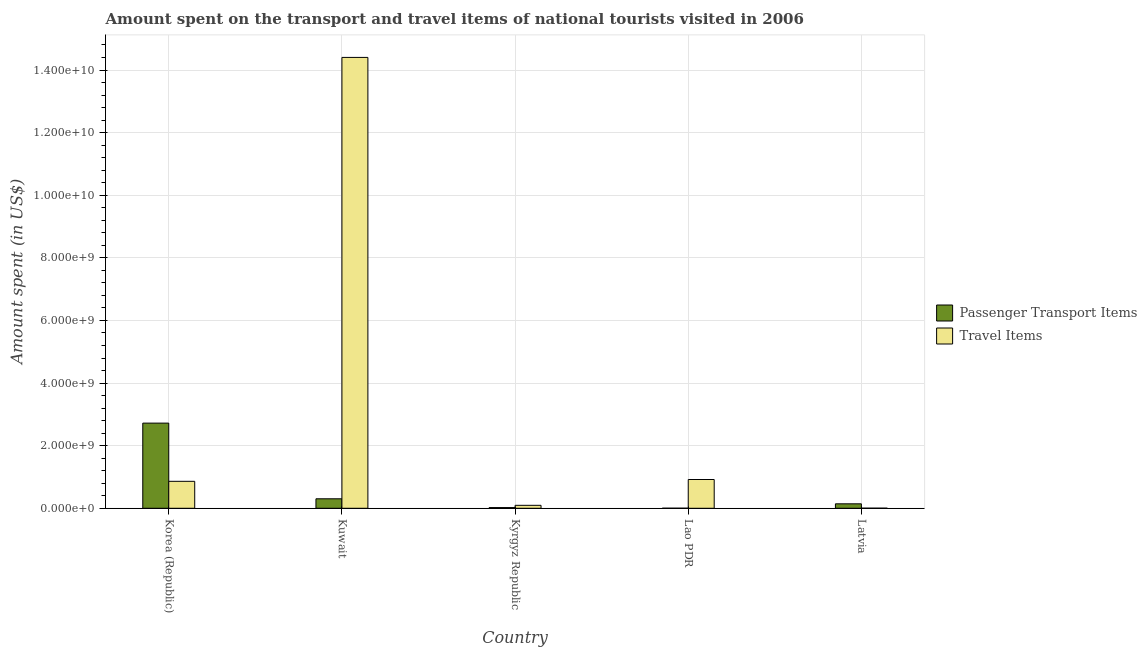How many bars are there on the 4th tick from the right?
Keep it short and to the point. 2. What is the label of the 4th group of bars from the left?
Provide a succinct answer. Lao PDR. In how many cases, is the number of bars for a given country not equal to the number of legend labels?
Your answer should be compact. 0. What is the amount spent in travel items in Kyrgyz Republic?
Ensure brevity in your answer.  9.40e+07. Across all countries, what is the maximum amount spent in travel items?
Offer a very short reply. 1.44e+1. Across all countries, what is the minimum amount spent in travel items?
Give a very brief answer. 2.80e+06. In which country was the amount spent on passenger transport items maximum?
Your answer should be compact. Korea (Republic). In which country was the amount spent on passenger transport items minimum?
Provide a short and direct response. Lao PDR. What is the total amount spent in travel items in the graph?
Offer a very short reply. 1.63e+1. What is the difference between the amount spent in travel items in Kuwait and that in Latvia?
Provide a succinct answer. 1.44e+1. What is the difference between the amount spent in travel items in Kyrgyz Republic and the amount spent on passenger transport items in Kuwait?
Your response must be concise. -2.09e+08. What is the average amount spent in travel items per country?
Provide a succinct answer. 3.26e+09. What is the difference between the amount spent on passenger transport items and amount spent in travel items in Korea (Republic)?
Provide a succinct answer. 1.86e+09. What is the ratio of the amount spent in travel items in Korea (Republic) to that in Lao PDR?
Ensure brevity in your answer.  0.94. What is the difference between the highest and the second highest amount spent in travel items?
Give a very brief answer. 1.35e+1. What is the difference between the highest and the lowest amount spent on passenger transport items?
Keep it short and to the point. 2.72e+09. What does the 2nd bar from the left in Kyrgyz Republic represents?
Your answer should be compact. Travel Items. What does the 1st bar from the right in Lao PDR represents?
Offer a terse response. Travel Items. What is the difference between two consecutive major ticks on the Y-axis?
Your answer should be very brief. 2.00e+09. Are the values on the major ticks of Y-axis written in scientific E-notation?
Ensure brevity in your answer.  Yes. Does the graph contain grids?
Keep it short and to the point. Yes. Where does the legend appear in the graph?
Give a very brief answer. Center right. How many legend labels are there?
Provide a succinct answer. 2. How are the legend labels stacked?
Your response must be concise. Vertical. What is the title of the graph?
Offer a very short reply. Amount spent on the transport and travel items of national tourists visited in 2006. What is the label or title of the Y-axis?
Offer a very short reply. Amount spent (in US$). What is the Amount spent (in US$) in Passenger Transport Items in Korea (Republic)?
Your response must be concise. 2.72e+09. What is the Amount spent (in US$) in Travel Items in Korea (Republic)?
Offer a very short reply. 8.61e+08. What is the Amount spent (in US$) in Passenger Transport Items in Kuwait?
Your response must be concise. 3.03e+08. What is the Amount spent (in US$) in Travel Items in Kuwait?
Provide a succinct answer. 1.44e+1. What is the Amount spent (in US$) in Passenger Transport Items in Kyrgyz Republic?
Give a very brief answer. 2.20e+07. What is the Amount spent (in US$) of Travel Items in Kyrgyz Republic?
Offer a very short reply. 9.40e+07. What is the Amount spent (in US$) in Travel Items in Lao PDR?
Make the answer very short. 9.19e+08. What is the Amount spent (in US$) of Passenger Transport Items in Latvia?
Provide a succinct answer. 1.42e+08. What is the Amount spent (in US$) in Travel Items in Latvia?
Make the answer very short. 2.80e+06. Across all countries, what is the maximum Amount spent (in US$) of Passenger Transport Items?
Provide a short and direct response. 2.72e+09. Across all countries, what is the maximum Amount spent (in US$) in Travel Items?
Provide a succinct answer. 1.44e+1. Across all countries, what is the minimum Amount spent (in US$) in Passenger Transport Items?
Your answer should be very brief. 2.00e+06. Across all countries, what is the minimum Amount spent (in US$) in Travel Items?
Your response must be concise. 2.80e+06. What is the total Amount spent (in US$) of Passenger Transport Items in the graph?
Your response must be concise. 3.19e+09. What is the total Amount spent (in US$) of Travel Items in the graph?
Provide a short and direct response. 1.63e+1. What is the difference between the Amount spent (in US$) of Passenger Transport Items in Korea (Republic) and that in Kuwait?
Provide a short and direct response. 2.42e+09. What is the difference between the Amount spent (in US$) of Travel Items in Korea (Republic) and that in Kuwait?
Offer a very short reply. -1.35e+1. What is the difference between the Amount spent (in US$) of Passenger Transport Items in Korea (Republic) and that in Kyrgyz Republic?
Provide a short and direct response. 2.70e+09. What is the difference between the Amount spent (in US$) in Travel Items in Korea (Republic) and that in Kyrgyz Republic?
Make the answer very short. 7.67e+08. What is the difference between the Amount spent (in US$) in Passenger Transport Items in Korea (Republic) and that in Lao PDR?
Your answer should be very brief. 2.72e+09. What is the difference between the Amount spent (in US$) in Travel Items in Korea (Republic) and that in Lao PDR?
Make the answer very short. -5.80e+07. What is the difference between the Amount spent (in US$) of Passenger Transport Items in Korea (Republic) and that in Latvia?
Make the answer very short. 2.58e+09. What is the difference between the Amount spent (in US$) of Travel Items in Korea (Republic) and that in Latvia?
Offer a very short reply. 8.58e+08. What is the difference between the Amount spent (in US$) in Passenger Transport Items in Kuwait and that in Kyrgyz Republic?
Keep it short and to the point. 2.81e+08. What is the difference between the Amount spent (in US$) of Travel Items in Kuwait and that in Kyrgyz Republic?
Your answer should be very brief. 1.43e+1. What is the difference between the Amount spent (in US$) of Passenger Transport Items in Kuwait and that in Lao PDR?
Make the answer very short. 3.01e+08. What is the difference between the Amount spent (in US$) in Travel Items in Kuwait and that in Lao PDR?
Your response must be concise. 1.35e+1. What is the difference between the Amount spent (in US$) of Passenger Transport Items in Kuwait and that in Latvia?
Make the answer very short. 1.61e+08. What is the difference between the Amount spent (in US$) in Travel Items in Kuwait and that in Latvia?
Your answer should be compact. 1.44e+1. What is the difference between the Amount spent (in US$) of Passenger Transport Items in Kyrgyz Republic and that in Lao PDR?
Provide a succinct answer. 2.00e+07. What is the difference between the Amount spent (in US$) in Travel Items in Kyrgyz Republic and that in Lao PDR?
Make the answer very short. -8.25e+08. What is the difference between the Amount spent (in US$) in Passenger Transport Items in Kyrgyz Republic and that in Latvia?
Your answer should be compact. -1.20e+08. What is the difference between the Amount spent (in US$) of Travel Items in Kyrgyz Republic and that in Latvia?
Ensure brevity in your answer.  9.12e+07. What is the difference between the Amount spent (in US$) in Passenger Transport Items in Lao PDR and that in Latvia?
Your response must be concise. -1.40e+08. What is the difference between the Amount spent (in US$) in Travel Items in Lao PDR and that in Latvia?
Provide a succinct answer. 9.16e+08. What is the difference between the Amount spent (in US$) of Passenger Transport Items in Korea (Republic) and the Amount spent (in US$) of Travel Items in Kuwait?
Your answer should be very brief. -1.17e+1. What is the difference between the Amount spent (in US$) in Passenger Transport Items in Korea (Republic) and the Amount spent (in US$) in Travel Items in Kyrgyz Republic?
Provide a short and direct response. 2.63e+09. What is the difference between the Amount spent (in US$) of Passenger Transport Items in Korea (Republic) and the Amount spent (in US$) of Travel Items in Lao PDR?
Your response must be concise. 1.80e+09. What is the difference between the Amount spent (in US$) in Passenger Transport Items in Korea (Republic) and the Amount spent (in US$) in Travel Items in Latvia?
Make the answer very short. 2.72e+09. What is the difference between the Amount spent (in US$) of Passenger Transport Items in Kuwait and the Amount spent (in US$) of Travel Items in Kyrgyz Republic?
Your answer should be compact. 2.09e+08. What is the difference between the Amount spent (in US$) of Passenger Transport Items in Kuwait and the Amount spent (in US$) of Travel Items in Lao PDR?
Ensure brevity in your answer.  -6.16e+08. What is the difference between the Amount spent (in US$) of Passenger Transport Items in Kuwait and the Amount spent (in US$) of Travel Items in Latvia?
Offer a terse response. 3.00e+08. What is the difference between the Amount spent (in US$) of Passenger Transport Items in Kyrgyz Republic and the Amount spent (in US$) of Travel Items in Lao PDR?
Offer a terse response. -8.97e+08. What is the difference between the Amount spent (in US$) in Passenger Transport Items in Kyrgyz Republic and the Amount spent (in US$) in Travel Items in Latvia?
Offer a very short reply. 1.92e+07. What is the difference between the Amount spent (in US$) of Passenger Transport Items in Lao PDR and the Amount spent (in US$) of Travel Items in Latvia?
Your answer should be compact. -8.00e+05. What is the average Amount spent (in US$) of Passenger Transport Items per country?
Give a very brief answer. 6.38e+08. What is the average Amount spent (in US$) of Travel Items per country?
Make the answer very short. 3.26e+09. What is the difference between the Amount spent (in US$) in Passenger Transport Items and Amount spent (in US$) in Travel Items in Korea (Republic)?
Keep it short and to the point. 1.86e+09. What is the difference between the Amount spent (in US$) in Passenger Transport Items and Amount spent (in US$) in Travel Items in Kuwait?
Provide a short and direct response. -1.41e+1. What is the difference between the Amount spent (in US$) of Passenger Transport Items and Amount spent (in US$) of Travel Items in Kyrgyz Republic?
Your answer should be compact. -7.20e+07. What is the difference between the Amount spent (in US$) in Passenger Transport Items and Amount spent (in US$) in Travel Items in Lao PDR?
Your response must be concise. -9.17e+08. What is the difference between the Amount spent (in US$) of Passenger Transport Items and Amount spent (in US$) of Travel Items in Latvia?
Make the answer very short. 1.39e+08. What is the ratio of the Amount spent (in US$) in Passenger Transport Items in Korea (Republic) to that in Kuwait?
Ensure brevity in your answer.  8.98. What is the ratio of the Amount spent (in US$) of Travel Items in Korea (Republic) to that in Kuwait?
Give a very brief answer. 0.06. What is the ratio of the Amount spent (in US$) in Passenger Transport Items in Korea (Republic) to that in Kyrgyz Republic?
Your answer should be very brief. 123.64. What is the ratio of the Amount spent (in US$) in Travel Items in Korea (Republic) to that in Kyrgyz Republic?
Make the answer very short. 9.16. What is the ratio of the Amount spent (in US$) of Passenger Transport Items in Korea (Republic) to that in Lao PDR?
Your answer should be compact. 1360. What is the ratio of the Amount spent (in US$) in Travel Items in Korea (Republic) to that in Lao PDR?
Offer a terse response. 0.94. What is the ratio of the Amount spent (in US$) in Passenger Transport Items in Korea (Republic) to that in Latvia?
Your answer should be very brief. 19.15. What is the ratio of the Amount spent (in US$) of Travel Items in Korea (Republic) to that in Latvia?
Your answer should be very brief. 307.5. What is the ratio of the Amount spent (in US$) in Passenger Transport Items in Kuwait to that in Kyrgyz Republic?
Your response must be concise. 13.77. What is the ratio of the Amount spent (in US$) in Travel Items in Kuwait to that in Kyrgyz Republic?
Provide a short and direct response. 153.21. What is the ratio of the Amount spent (in US$) of Passenger Transport Items in Kuwait to that in Lao PDR?
Provide a succinct answer. 151.5. What is the ratio of the Amount spent (in US$) of Travel Items in Kuwait to that in Lao PDR?
Make the answer very short. 15.67. What is the ratio of the Amount spent (in US$) of Passenger Transport Items in Kuwait to that in Latvia?
Make the answer very short. 2.13. What is the ratio of the Amount spent (in US$) in Travel Items in Kuwait to that in Latvia?
Keep it short and to the point. 5143.57. What is the ratio of the Amount spent (in US$) of Travel Items in Kyrgyz Republic to that in Lao PDR?
Ensure brevity in your answer.  0.1. What is the ratio of the Amount spent (in US$) of Passenger Transport Items in Kyrgyz Republic to that in Latvia?
Provide a succinct answer. 0.15. What is the ratio of the Amount spent (in US$) of Travel Items in Kyrgyz Republic to that in Latvia?
Provide a succinct answer. 33.57. What is the ratio of the Amount spent (in US$) in Passenger Transport Items in Lao PDR to that in Latvia?
Your response must be concise. 0.01. What is the ratio of the Amount spent (in US$) of Travel Items in Lao PDR to that in Latvia?
Keep it short and to the point. 328.21. What is the difference between the highest and the second highest Amount spent (in US$) in Passenger Transport Items?
Offer a very short reply. 2.42e+09. What is the difference between the highest and the second highest Amount spent (in US$) in Travel Items?
Offer a very short reply. 1.35e+1. What is the difference between the highest and the lowest Amount spent (in US$) of Passenger Transport Items?
Your response must be concise. 2.72e+09. What is the difference between the highest and the lowest Amount spent (in US$) of Travel Items?
Offer a terse response. 1.44e+1. 